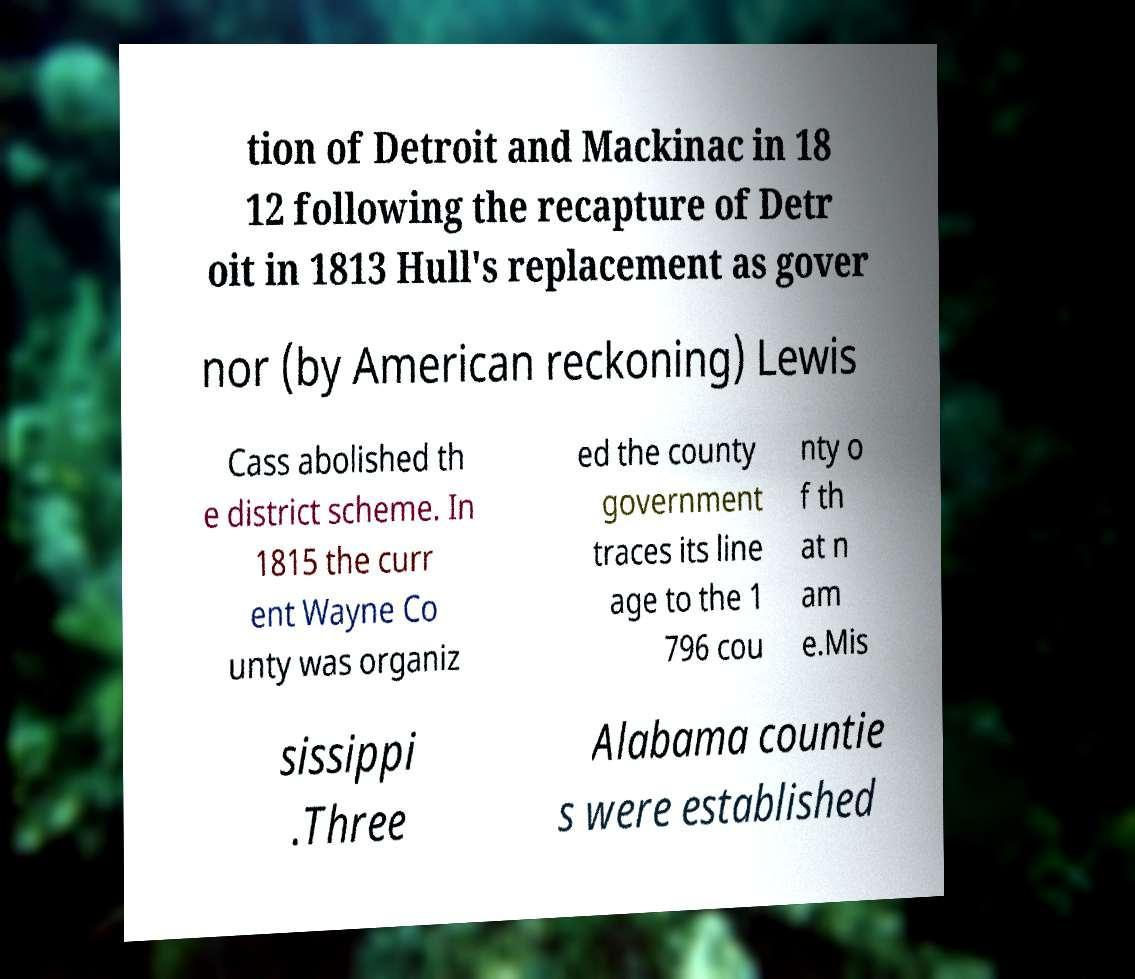What messages or text are displayed in this image? I need them in a readable, typed format. tion of Detroit and Mackinac in 18 12 following the recapture of Detr oit in 1813 Hull's replacement as gover nor (by American reckoning) Lewis Cass abolished th e district scheme. In 1815 the curr ent Wayne Co unty was organiz ed the county government traces its line age to the 1 796 cou nty o f th at n am e.Mis sissippi .Three Alabama countie s were established 